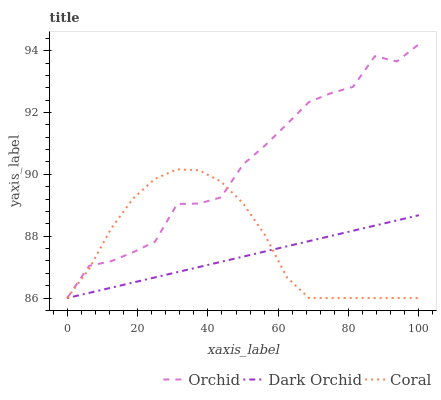Does Dark Orchid have the minimum area under the curve?
Answer yes or no. Yes. Does Orchid have the maximum area under the curve?
Answer yes or no. Yes. Does Orchid have the minimum area under the curve?
Answer yes or no. No. Does Dark Orchid have the maximum area under the curve?
Answer yes or no. No. Is Dark Orchid the smoothest?
Answer yes or no. Yes. Is Orchid the roughest?
Answer yes or no. Yes. Is Orchid the smoothest?
Answer yes or no. No. Is Dark Orchid the roughest?
Answer yes or no. No. Does Coral have the lowest value?
Answer yes or no. Yes. Does Orchid have the highest value?
Answer yes or no. Yes. Does Dark Orchid have the highest value?
Answer yes or no. No. Does Coral intersect Orchid?
Answer yes or no. Yes. Is Coral less than Orchid?
Answer yes or no. No. Is Coral greater than Orchid?
Answer yes or no. No. 